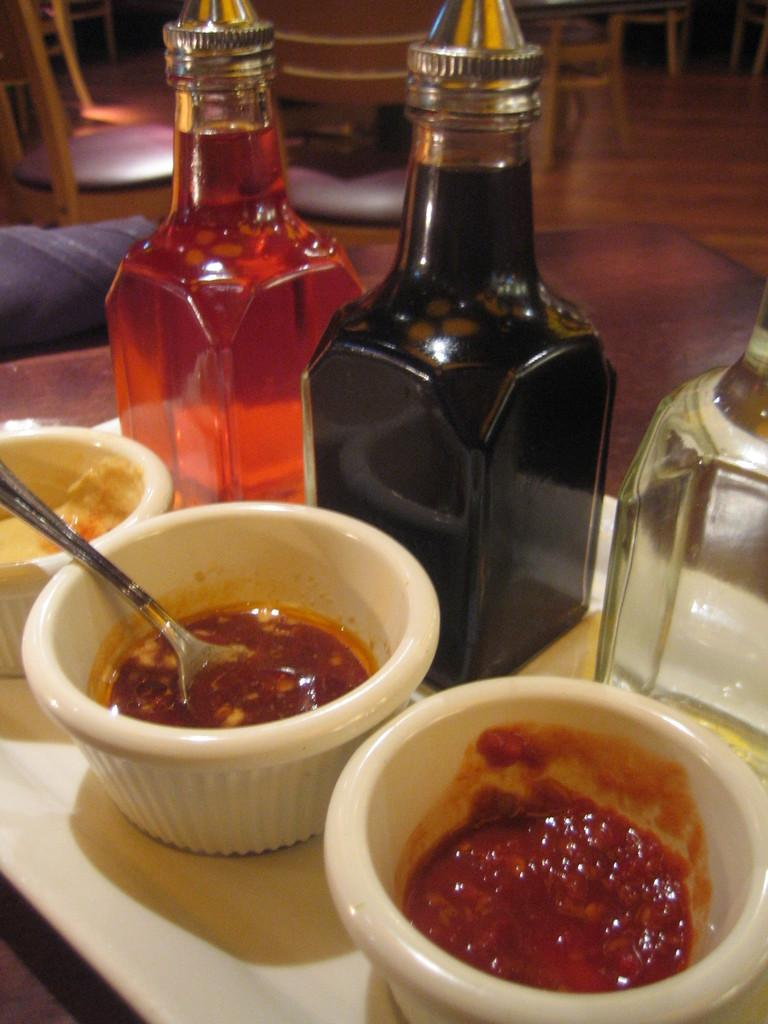What objects are present in the image that can hold food? There are bowls in the image that hold food. What is inside the bowls? There is food in the bowls. How many bottles are visible in the image? There are three bottles in the image. What type of furniture is present in the image? There are chairs and tables in the image. How do the pets in the image interact with the food? There are no pets present in the image, so they cannot interact with the food. What type of driving is depicted in the image? There is no driving depicted in the image; it features bowls, food, bottles, chairs, and tables. 